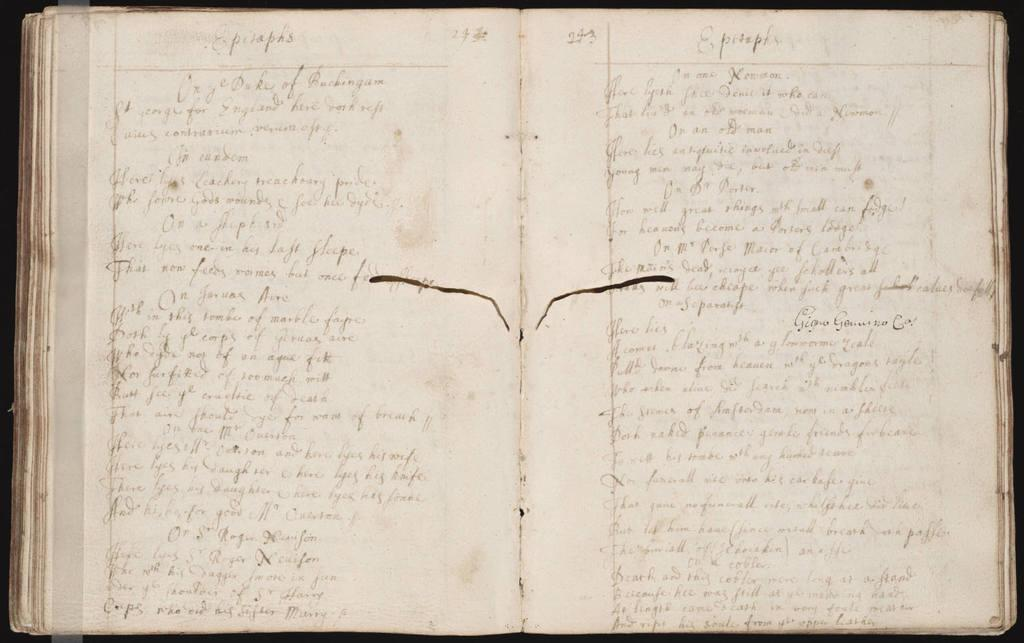What is the main object in the image? There is a book in the image. What is the state of the book in the image? The book is opened. What can be seen on the pages of the book? There are texts on the two pages of the book. How would you describe the background of the image? The background of the image is dark in color. What type of popcorn is being served to the donkey in the image? There is no popcorn or donkey present in the image; it features a book with texts on its pages. 